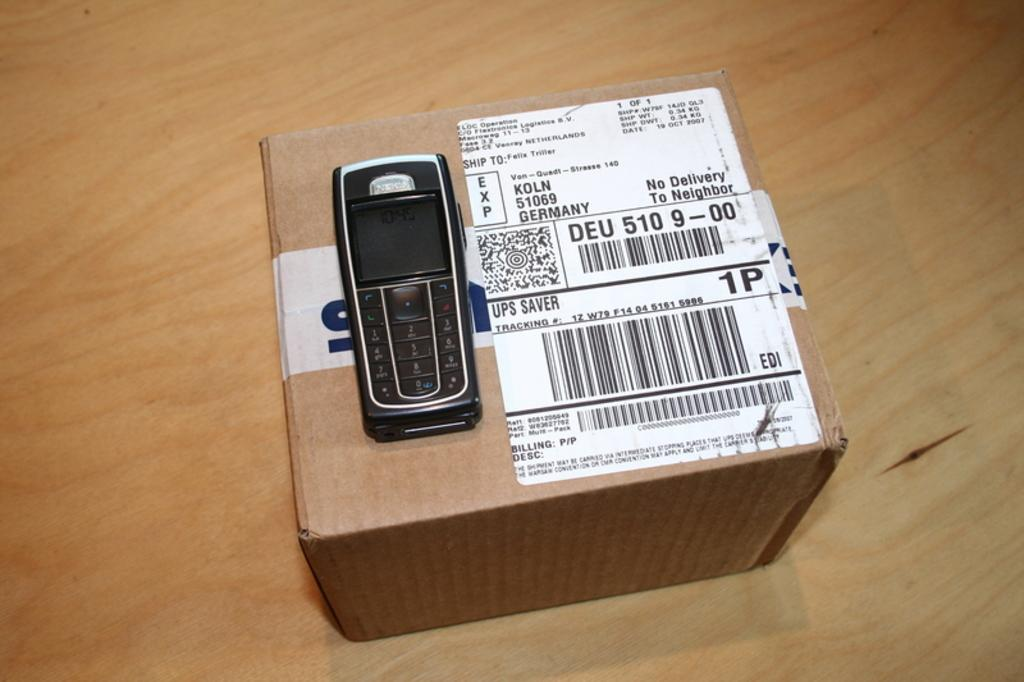<image>
Present a compact description of the photo's key features. An old cell phone sitting on a box from Germany that says no delivery to neighbors. 